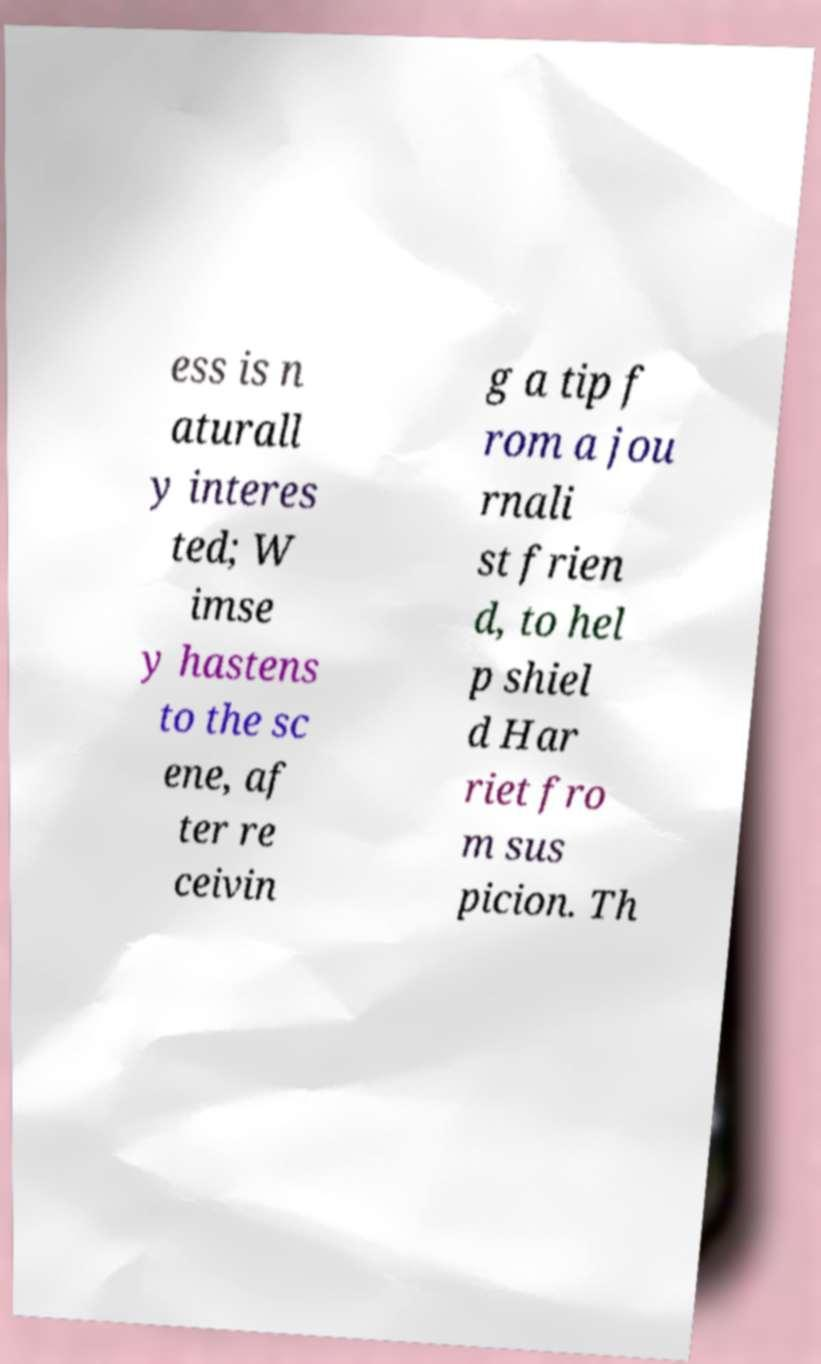Could you extract and type out the text from this image? ess is n aturall y interes ted; W imse y hastens to the sc ene, af ter re ceivin g a tip f rom a jou rnali st frien d, to hel p shiel d Har riet fro m sus picion. Th 